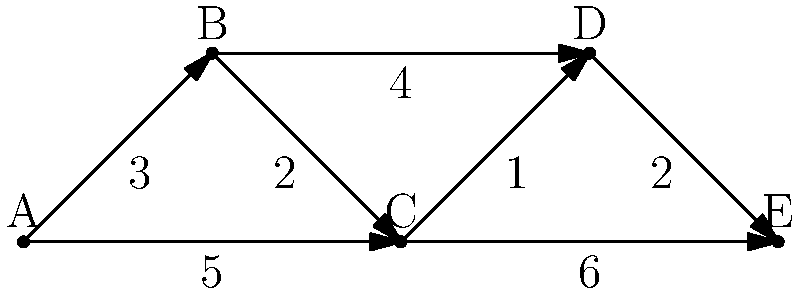As a luxury tour guide in Maharashtra, you're planning an exclusive sightseeing route for high-end clients. The graph represents luxurious attractions (nodes) and the travel times between them (edge weights). Starting from point A, what's the shortest time to visit all attractions and end at point E, ensuring the most efficient and comfortable journey for your VIP guests? To find the shortest time to visit all attractions starting from A and ending at E, we need to find the shortest path that visits all nodes. This is a Traveling Salesman Problem variant.

Step 1: List all possible paths from A to E visiting all nodes:
1. A → B → C → D → E
2. A → B → D → C → E
3. A → C → B → D → E
4. A → C → D → B → E

Step 2: Calculate the total time for each path:

1. A → B → C → D → E:
   $3 + 2 + 1 + 2 = 8$

2. A → B → D → C → E:
   $3 + 4 + 1 + 6 = 14$

3. A → C → B → D → E:
   $5 + 2 + 4 + 2 = 13$

4. A → C → D → B → E:
   $5 + 1 + 4 + 2 = 12$

Step 3: Identify the shortest path:
The shortest path is A → B → C → D → E, with a total time of 8 units.

This route ensures the most efficient and comfortable journey for the VIP guests, minimizing travel time between luxurious attractions.
Answer: 8 time units 